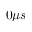<formula> <loc_0><loc_0><loc_500><loc_500>0 \mu s</formula> 